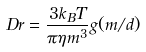<formula> <loc_0><loc_0><loc_500><loc_500>\ D r = \frac { 3 k _ { B } T } { \pi \eta \L m ^ { 3 } } g ( \L m / d )</formula> 